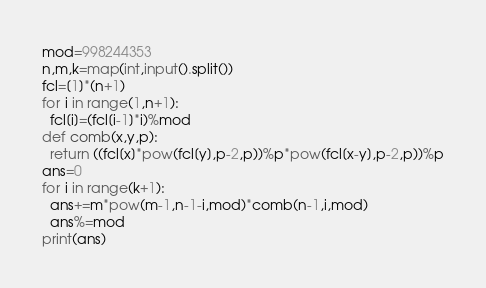<code> <loc_0><loc_0><loc_500><loc_500><_Python_>mod=998244353
n,m,k=map(int,input().split())
fcl=[1]*(n+1)
for i in range(1,n+1):
  fcl[i]=(fcl[i-1]*i)%mod
def comb(x,y,p):
  return ((fcl[x]*pow(fcl[y],p-2,p))%p*pow(fcl[x-y],p-2,p))%p
ans=0
for i in range(k+1):
  ans+=m*pow(m-1,n-1-i,mod)*comb(n-1,i,mod)
  ans%=mod
print(ans)</code> 